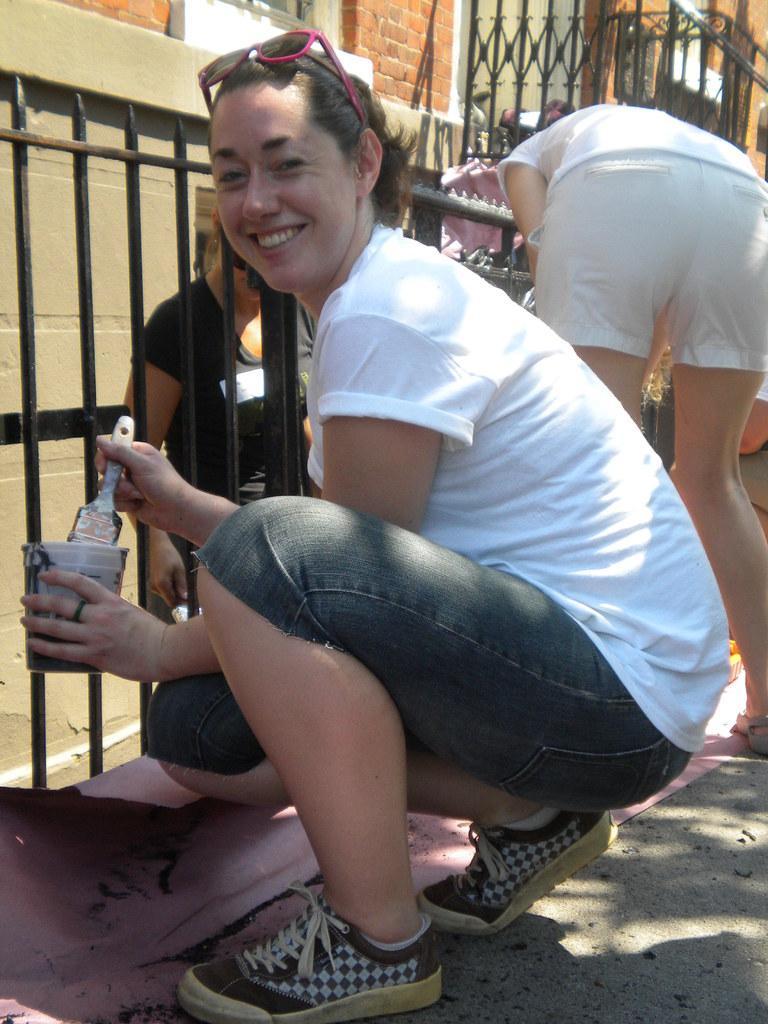Please provide a concise description of this image. In this image I see few persons and I see a woman over here who is smiling and I see that she is wearing white t-shirt and shorts and I see that she is holding a paint brush in one hand and other thing in other hand and I see the path and I see the fencing and in the background I see the wall. 